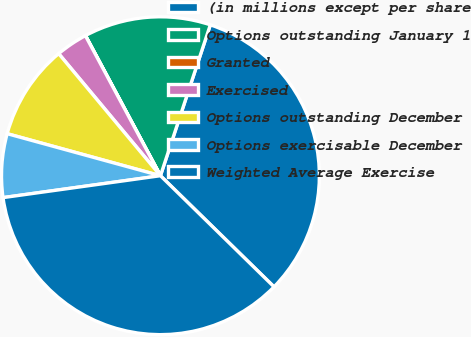<chart> <loc_0><loc_0><loc_500><loc_500><pie_chart><fcel>(in millions except per share<fcel>Options outstanding January 1<fcel>Granted<fcel>Exercised<fcel>Options outstanding December<fcel>Options exercisable December<fcel>Weighted Average Exercise<nl><fcel>32.24%<fcel>12.9%<fcel>0.01%<fcel>3.23%<fcel>9.68%<fcel>6.46%<fcel>35.47%<nl></chart> 